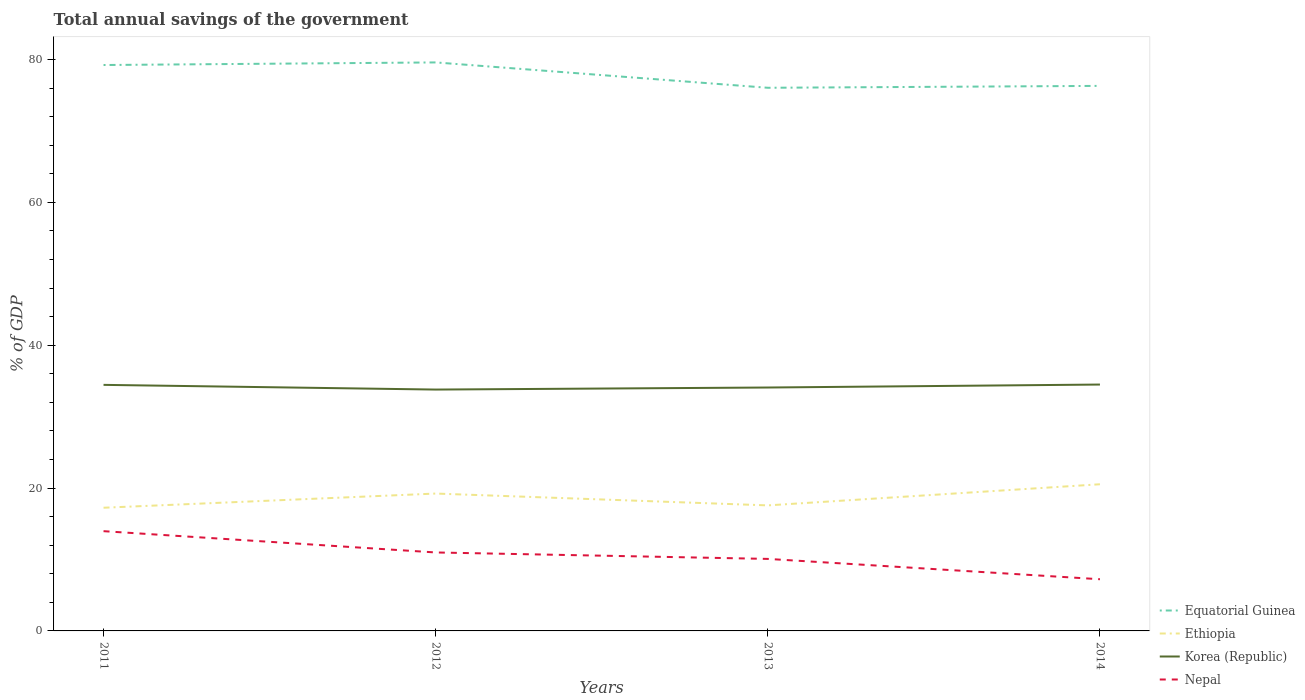Does the line corresponding to Nepal intersect with the line corresponding to Equatorial Guinea?
Provide a succinct answer. No. Is the number of lines equal to the number of legend labels?
Provide a succinct answer. Yes. Across all years, what is the maximum total annual savings of the government in Korea (Republic)?
Your answer should be very brief. 33.8. What is the total total annual savings of the government in Korea (Republic) in the graph?
Offer a very short reply. -0.04. What is the difference between the highest and the second highest total annual savings of the government in Nepal?
Your response must be concise. 6.73. What is the difference between the highest and the lowest total annual savings of the government in Nepal?
Your response must be concise. 2. Is the total annual savings of the government in Equatorial Guinea strictly greater than the total annual savings of the government in Ethiopia over the years?
Give a very brief answer. No. What is the difference between two consecutive major ticks on the Y-axis?
Offer a very short reply. 20. Does the graph contain any zero values?
Offer a terse response. No. How many legend labels are there?
Ensure brevity in your answer.  4. How are the legend labels stacked?
Keep it short and to the point. Vertical. What is the title of the graph?
Ensure brevity in your answer.  Total annual savings of the government. Does "Brunei Darussalam" appear as one of the legend labels in the graph?
Your answer should be compact. No. What is the label or title of the Y-axis?
Your answer should be very brief. % of GDP. What is the % of GDP in Equatorial Guinea in 2011?
Your answer should be very brief. 79.24. What is the % of GDP of Ethiopia in 2011?
Your response must be concise. 17.25. What is the % of GDP of Korea (Republic) in 2011?
Your answer should be compact. 34.45. What is the % of GDP of Nepal in 2011?
Your answer should be very brief. 13.97. What is the % of GDP of Equatorial Guinea in 2012?
Your answer should be very brief. 79.6. What is the % of GDP of Ethiopia in 2012?
Your response must be concise. 19.23. What is the % of GDP in Korea (Republic) in 2012?
Your response must be concise. 33.8. What is the % of GDP in Nepal in 2012?
Offer a terse response. 10.99. What is the % of GDP in Equatorial Guinea in 2013?
Provide a short and direct response. 76.05. What is the % of GDP of Ethiopia in 2013?
Ensure brevity in your answer.  17.58. What is the % of GDP of Korea (Republic) in 2013?
Offer a very short reply. 34.08. What is the % of GDP of Nepal in 2013?
Provide a succinct answer. 10.08. What is the % of GDP in Equatorial Guinea in 2014?
Keep it short and to the point. 76.32. What is the % of GDP in Ethiopia in 2014?
Provide a succinct answer. 20.54. What is the % of GDP in Korea (Republic) in 2014?
Your answer should be very brief. 34.5. What is the % of GDP in Nepal in 2014?
Your response must be concise. 7.24. Across all years, what is the maximum % of GDP in Equatorial Guinea?
Provide a short and direct response. 79.6. Across all years, what is the maximum % of GDP of Ethiopia?
Ensure brevity in your answer.  20.54. Across all years, what is the maximum % of GDP of Korea (Republic)?
Offer a very short reply. 34.5. Across all years, what is the maximum % of GDP of Nepal?
Make the answer very short. 13.97. Across all years, what is the minimum % of GDP of Equatorial Guinea?
Keep it short and to the point. 76.05. Across all years, what is the minimum % of GDP of Ethiopia?
Offer a very short reply. 17.25. Across all years, what is the minimum % of GDP of Korea (Republic)?
Your answer should be very brief. 33.8. Across all years, what is the minimum % of GDP in Nepal?
Make the answer very short. 7.24. What is the total % of GDP of Equatorial Guinea in the graph?
Your response must be concise. 311.21. What is the total % of GDP in Ethiopia in the graph?
Your answer should be compact. 74.6. What is the total % of GDP of Korea (Republic) in the graph?
Your response must be concise. 136.83. What is the total % of GDP in Nepal in the graph?
Ensure brevity in your answer.  42.28. What is the difference between the % of GDP in Equatorial Guinea in 2011 and that in 2012?
Make the answer very short. -0.36. What is the difference between the % of GDP in Ethiopia in 2011 and that in 2012?
Keep it short and to the point. -1.99. What is the difference between the % of GDP in Korea (Republic) in 2011 and that in 2012?
Ensure brevity in your answer.  0.66. What is the difference between the % of GDP of Nepal in 2011 and that in 2012?
Your answer should be compact. 2.98. What is the difference between the % of GDP of Equatorial Guinea in 2011 and that in 2013?
Provide a short and direct response. 3.19. What is the difference between the % of GDP in Ethiopia in 2011 and that in 2013?
Your answer should be compact. -0.33. What is the difference between the % of GDP of Korea (Republic) in 2011 and that in 2013?
Ensure brevity in your answer.  0.37. What is the difference between the % of GDP in Nepal in 2011 and that in 2013?
Make the answer very short. 3.88. What is the difference between the % of GDP in Equatorial Guinea in 2011 and that in 2014?
Provide a succinct answer. 2.92. What is the difference between the % of GDP in Ethiopia in 2011 and that in 2014?
Provide a succinct answer. -3.29. What is the difference between the % of GDP in Korea (Republic) in 2011 and that in 2014?
Your answer should be compact. -0.04. What is the difference between the % of GDP of Nepal in 2011 and that in 2014?
Keep it short and to the point. 6.73. What is the difference between the % of GDP in Equatorial Guinea in 2012 and that in 2013?
Provide a short and direct response. 3.55. What is the difference between the % of GDP of Ethiopia in 2012 and that in 2013?
Make the answer very short. 1.66. What is the difference between the % of GDP of Korea (Republic) in 2012 and that in 2013?
Provide a succinct answer. -0.29. What is the difference between the % of GDP of Nepal in 2012 and that in 2013?
Your answer should be very brief. 0.9. What is the difference between the % of GDP of Equatorial Guinea in 2012 and that in 2014?
Your response must be concise. 3.29. What is the difference between the % of GDP of Ethiopia in 2012 and that in 2014?
Your answer should be compact. -1.3. What is the difference between the % of GDP in Korea (Republic) in 2012 and that in 2014?
Provide a succinct answer. -0.7. What is the difference between the % of GDP in Nepal in 2012 and that in 2014?
Keep it short and to the point. 3.75. What is the difference between the % of GDP of Equatorial Guinea in 2013 and that in 2014?
Offer a very short reply. -0.27. What is the difference between the % of GDP of Ethiopia in 2013 and that in 2014?
Keep it short and to the point. -2.96. What is the difference between the % of GDP in Korea (Republic) in 2013 and that in 2014?
Make the answer very short. -0.42. What is the difference between the % of GDP in Nepal in 2013 and that in 2014?
Keep it short and to the point. 2.85. What is the difference between the % of GDP in Equatorial Guinea in 2011 and the % of GDP in Ethiopia in 2012?
Your answer should be very brief. 60. What is the difference between the % of GDP in Equatorial Guinea in 2011 and the % of GDP in Korea (Republic) in 2012?
Your response must be concise. 45.44. What is the difference between the % of GDP in Equatorial Guinea in 2011 and the % of GDP in Nepal in 2012?
Keep it short and to the point. 68.25. What is the difference between the % of GDP of Ethiopia in 2011 and the % of GDP of Korea (Republic) in 2012?
Your answer should be compact. -16.55. What is the difference between the % of GDP of Ethiopia in 2011 and the % of GDP of Nepal in 2012?
Your answer should be very brief. 6.26. What is the difference between the % of GDP of Korea (Republic) in 2011 and the % of GDP of Nepal in 2012?
Give a very brief answer. 23.47. What is the difference between the % of GDP in Equatorial Guinea in 2011 and the % of GDP in Ethiopia in 2013?
Keep it short and to the point. 61.66. What is the difference between the % of GDP of Equatorial Guinea in 2011 and the % of GDP of Korea (Republic) in 2013?
Offer a very short reply. 45.16. What is the difference between the % of GDP of Equatorial Guinea in 2011 and the % of GDP of Nepal in 2013?
Your answer should be compact. 69.15. What is the difference between the % of GDP of Ethiopia in 2011 and the % of GDP of Korea (Republic) in 2013?
Your answer should be very brief. -16.83. What is the difference between the % of GDP of Ethiopia in 2011 and the % of GDP of Nepal in 2013?
Your response must be concise. 7.16. What is the difference between the % of GDP in Korea (Republic) in 2011 and the % of GDP in Nepal in 2013?
Your response must be concise. 24.37. What is the difference between the % of GDP of Equatorial Guinea in 2011 and the % of GDP of Ethiopia in 2014?
Give a very brief answer. 58.7. What is the difference between the % of GDP of Equatorial Guinea in 2011 and the % of GDP of Korea (Republic) in 2014?
Your answer should be very brief. 44.74. What is the difference between the % of GDP of Equatorial Guinea in 2011 and the % of GDP of Nepal in 2014?
Ensure brevity in your answer.  72. What is the difference between the % of GDP in Ethiopia in 2011 and the % of GDP in Korea (Republic) in 2014?
Provide a succinct answer. -17.25. What is the difference between the % of GDP in Ethiopia in 2011 and the % of GDP in Nepal in 2014?
Your answer should be very brief. 10.01. What is the difference between the % of GDP in Korea (Republic) in 2011 and the % of GDP in Nepal in 2014?
Offer a very short reply. 27.22. What is the difference between the % of GDP in Equatorial Guinea in 2012 and the % of GDP in Ethiopia in 2013?
Keep it short and to the point. 62.02. What is the difference between the % of GDP of Equatorial Guinea in 2012 and the % of GDP of Korea (Republic) in 2013?
Ensure brevity in your answer.  45.52. What is the difference between the % of GDP of Equatorial Guinea in 2012 and the % of GDP of Nepal in 2013?
Offer a terse response. 69.52. What is the difference between the % of GDP in Ethiopia in 2012 and the % of GDP in Korea (Republic) in 2013?
Offer a very short reply. -14.85. What is the difference between the % of GDP in Ethiopia in 2012 and the % of GDP in Nepal in 2013?
Provide a short and direct response. 9.15. What is the difference between the % of GDP in Korea (Republic) in 2012 and the % of GDP in Nepal in 2013?
Your answer should be very brief. 23.71. What is the difference between the % of GDP of Equatorial Guinea in 2012 and the % of GDP of Ethiopia in 2014?
Your answer should be very brief. 59.07. What is the difference between the % of GDP in Equatorial Guinea in 2012 and the % of GDP in Korea (Republic) in 2014?
Provide a succinct answer. 45.11. What is the difference between the % of GDP of Equatorial Guinea in 2012 and the % of GDP of Nepal in 2014?
Make the answer very short. 72.36. What is the difference between the % of GDP in Ethiopia in 2012 and the % of GDP in Korea (Republic) in 2014?
Make the answer very short. -15.26. What is the difference between the % of GDP in Ethiopia in 2012 and the % of GDP in Nepal in 2014?
Ensure brevity in your answer.  12. What is the difference between the % of GDP of Korea (Republic) in 2012 and the % of GDP of Nepal in 2014?
Provide a short and direct response. 26.56. What is the difference between the % of GDP in Equatorial Guinea in 2013 and the % of GDP in Ethiopia in 2014?
Provide a succinct answer. 55.52. What is the difference between the % of GDP in Equatorial Guinea in 2013 and the % of GDP in Korea (Republic) in 2014?
Your response must be concise. 41.55. What is the difference between the % of GDP of Equatorial Guinea in 2013 and the % of GDP of Nepal in 2014?
Offer a terse response. 68.81. What is the difference between the % of GDP of Ethiopia in 2013 and the % of GDP of Korea (Republic) in 2014?
Your answer should be very brief. -16.92. What is the difference between the % of GDP of Ethiopia in 2013 and the % of GDP of Nepal in 2014?
Offer a very short reply. 10.34. What is the difference between the % of GDP in Korea (Republic) in 2013 and the % of GDP in Nepal in 2014?
Keep it short and to the point. 26.84. What is the average % of GDP in Equatorial Guinea per year?
Your answer should be compact. 77.8. What is the average % of GDP of Ethiopia per year?
Ensure brevity in your answer.  18.65. What is the average % of GDP of Korea (Republic) per year?
Give a very brief answer. 34.21. What is the average % of GDP of Nepal per year?
Ensure brevity in your answer.  10.57. In the year 2011, what is the difference between the % of GDP of Equatorial Guinea and % of GDP of Ethiopia?
Give a very brief answer. 61.99. In the year 2011, what is the difference between the % of GDP of Equatorial Guinea and % of GDP of Korea (Republic)?
Offer a very short reply. 44.78. In the year 2011, what is the difference between the % of GDP of Equatorial Guinea and % of GDP of Nepal?
Offer a very short reply. 65.27. In the year 2011, what is the difference between the % of GDP in Ethiopia and % of GDP in Korea (Republic)?
Give a very brief answer. -17.21. In the year 2011, what is the difference between the % of GDP in Ethiopia and % of GDP in Nepal?
Make the answer very short. 3.28. In the year 2011, what is the difference between the % of GDP in Korea (Republic) and % of GDP in Nepal?
Provide a short and direct response. 20.49. In the year 2012, what is the difference between the % of GDP of Equatorial Guinea and % of GDP of Ethiopia?
Keep it short and to the point. 60.37. In the year 2012, what is the difference between the % of GDP in Equatorial Guinea and % of GDP in Korea (Republic)?
Provide a succinct answer. 45.81. In the year 2012, what is the difference between the % of GDP of Equatorial Guinea and % of GDP of Nepal?
Offer a terse response. 68.62. In the year 2012, what is the difference between the % of GDP in Ethiopia and % of GDP in Korea (Republic)?
Make the answer very short. -14.56. In the year 2012, what is the difference between the % of GDP in Ethiopia and % of GDP in Nepal?
Make the answer very short. 8.25. In the year 2012, what is the difference between the % of GDP in Korea (Republic) and % of GDP in Nepal?
Make the answer very short. 22.81. In the year 2013, what is the difference between the % of GDP of Equatorial Guinea and % of GDP of Ethiopia?
Your answer should be very brief. 58.47. In the year 2013, what is the difference between the % of GDP of Equatorial Guinea and % of GDP of Korea (Republic)?
Offer a very short reply. 41.97. In the year 2013, what is the difference between the % of GDP of Equatorial Guinea and % of GDP of Nepal?
Your response must be concise. 65.97. In the year 2013, what is the difference between the % of GDP in Ethiopia and % of GDP in Korea (Republic)?
Offer a terse response. -16.5. In the year 2013, what is the difference between the % of GDP in Ethiopia and % of GDP in Nepal?
Offer a very short reply. 7.49. In the year 2013, what is the difference between the % of GDP in Korea (Republic) and % of GDP in Nepal?
Provide a succinct answer. 24. In the year 2014, what is the difference between the % of GDP in Equatorial Guinea and % of GDP in Ethiopia?
Offer a very short reply. 55.78. In the year 2014, what is the difference between the % of GDP of Equatorial Guinea and % of GDP of Korea (Republic)?
Your response must be concise. 41.82. In the year 2014, what is the difference between the % of GDP in Equatorial Guinea and % of GDP in Nepal?
Your answer should be compact. 69.08. In the year 2014, what is the difference between the % of GDP in Ethiopia and % of GDP in Korea (Republic)?
Offer a very short reply. -13.96. In the year 2014, what is the difference between the % of GDP in Ethiopia and % of GDP in Nepal?
Your answer should be compact. 13.3. In the year 2014, what is the difference between the % of GDP in Korea (Republic) and % of GDP in Nepal?
Give a very brief answer. 27.26. What is the ratio of the % of GDP in Equatorial Guinea in 2011 to that in 2012?
Offer a terse response. 1. What is the ratio of the % of GDP in Ethiopia in 2011 to that in 2012?
Your answer should be very brief. 0.9. What is the ratio of the % of GDP in Korea (Republic) in 2011 to that in 2012?
Your answer should be very brief. 1.02. What is the ratio of the % of GDP in Nepal in 2011 to that in 2012?
Your answer should be very brief. 1.27. What is the ratio of the % of GDP of Equatorial Guinea in 2011 to that in 2013?
Your response must be concise. 1.04. What is the ratio of the % of GDP of Ethiopia in 2011 to that in 2013?
Give a very brief answer. 0.98. What is the ratio of the % of GDP in Korea (Republic) in 2011 to that in 2013?
Offer a very short reply. 1.01. What is the ratio of the % of GDP of Nepal in 2011 to that in 2013?
Provide a short and direct response. 1.39. What is the ratio of the % of GDP in Equatorial Guinea in 2011 to that in 2014?
Keep it short and to the point. 1.04. What is the ratio of the % of GDP in Ethiopia in 2011 to that in 2014?
Your answer should be very brief. 0.84. What is the ratio of the % of GDP in Nepal in 2011 to that in 2014?
Make the answer very short. 1.93. What is the ratio of the % of GDP in Equatorial Guinea in 2012 to that in 2013?
Ensure brevity in your answer.  1.05. What is the ratio of the % of GDP of Ethiopia in 2012 to that in 2013?
Provide a succinct answer. 1.09. What is the ratio of the % of GDP in Nepal in 2012 to that in 2013?
Your answer should be compact. 1.09. What is the ratio of the % of GDP in Equatorial Guinea in 2012 to that in 2014?
Make the answer very short. 1.04. What is the ratio of the % of GDP in Ethiopia in 2012 to that in 2014?
Your response must be concise. 0.94. What is the ratio of the % of GDP in Korea (Republic) in 2012 to that in 2014?
Offer a very short reply. 0.98. What is the ratio of the % of GDP of Nepal in 2012 to that in 2014?
Keep it short and to the point. 1.52. What is the ratio of the % of GDP in Equatorial Guinea in 2013 to that in 2014?
Provide a succinct answer. 1. What is the ratio of the % of GDP in Ethiopia in 2013 to that in 2014?
Keep it short and to the point. 0.86. What is the ratio of the % of GDP in Nepal in 2013 to that in 2014?
Provide a succinct answer. 1.39. What is the difference between the highest and the second highest % of GDP of Equatorial Guinea?
Provide a succinct answer. 0.36. What is the difference between the highest and the second highest % of GDP of Ethiopia?
Keep it short and to the point. 1.3. What is the difference between the highest and the second highest % of GDP of Korea (Republic)?
Your response must be concise. 0.04. What is the difference between the highest and the second highest % of GDP in Nepal?
Provide a succinct answer. 2.98. What is the difference between the highest and the lowest % of GDP in Equatorial Guinea?
Offer a very short reply. 3.55. What is the difference between the highest and the lowest % of GDP in Ethiopia?
Your answer should be very brief. 3.29. What is the difference between the highest and the lowest % of GDP of Korea (Republic)?
Keep it short and to the point. 0.7. What is the difference between the highest and the lowest % of GDP of Nepal?
Your answer should be compact. 6.73. 